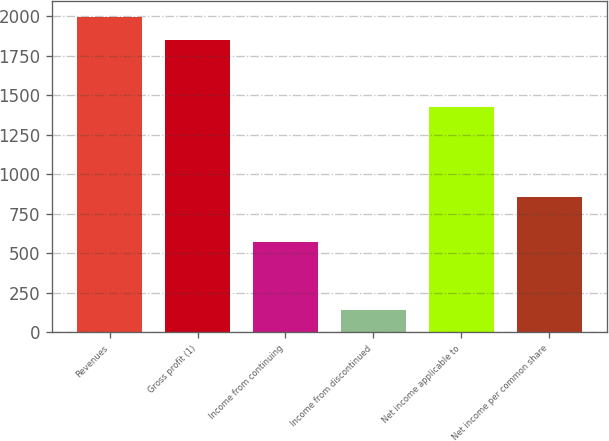<chart> <loc_0><loc_0><loc_500><loc_500><bar_chart><fcel>Revenues<fcel>Gross profit (1)<fcel>Income from continuing<fcel>Income from discontinued<fcel>Net income applicable to<fcel>Net income per common share<nl><fcel>1993.56<fcel>1851.17<fcel>569.66<fcel>142.49<fcel>1424<fcel>854.44<nl></chart> 